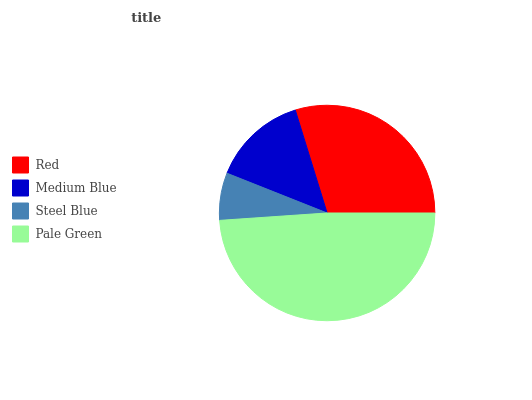Is Steel Blue the minimum?
Answer yes or no. Yes. Is Pale Green the maximum?
Answer yes or no. Yes. Is Medium Blue the minimum?
Answer yes or no. No. Is Medium Blue the maximum?
Answer yes or no. No. Is Red greater than Medium Blue?
Answer yes or no. Yes. Is Medium Blue less than Red?
Answer yes or no. Yes. Is Medium Blue greater than Red?
Answer yes or no. No. Is Red less than Medium Blue?
Answer yes or no. No. Is Red the high median?
Answer yes or no. Yes. Is Medium Blue the low median?
Answer yes or no. Yes. Is Pale Green the high median?
Answer yes or no. No. Is Red the low median?
Answer yes or no. No. 